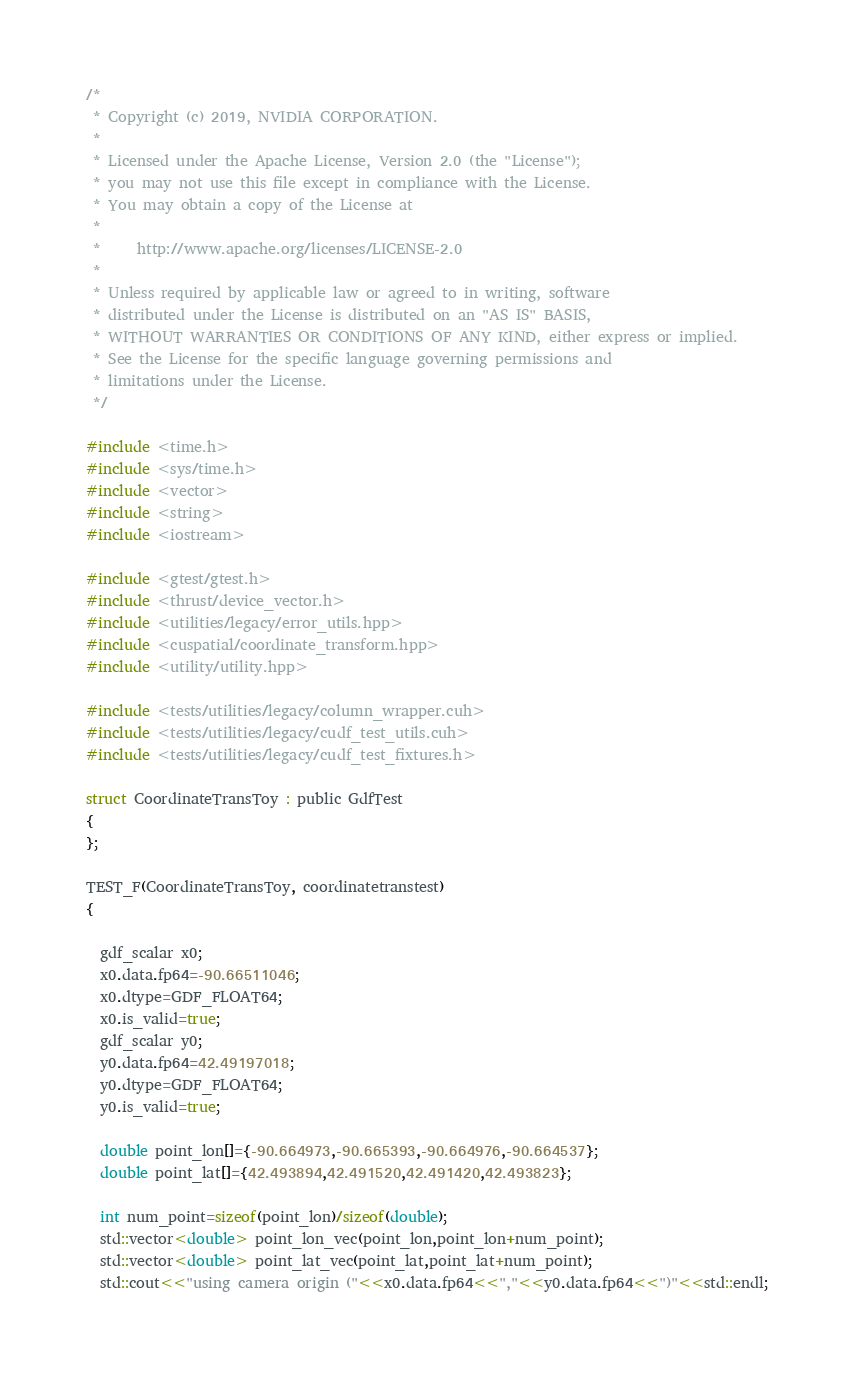Convert code to text. <code><loc_0><loc_0><loc_500><loc_500><_Cuda_>/*
 * Copyright (c) 2019, NVIDIA CORPORATION.
 *
 * Licensed under the Apache License, Version 2.0 (the "License");
 * you may not use this file except in compliance with the License.
 * You may obtain a copy of the License at
 *
 *     http://www.apache.org/licenses/LICENSE-2.0
 *
 * Unless required by applicable law or agreed to in writing, software
 * distributed under the License is distributed on an "AS IS" BASIS,
 * WITHOUT WARRANTIES OR CONDITIONS OF ANY KIND, either express or implied.
 * See the License for the specific language governing permissions and
 * limitations under the License.
 */

#include <time.h>
#include <sys/time.h>
#include <vector>
#include <string>
#include <iostream>

#include <gtest/gtest.h>
#include <thrust/device_vector.h>
#include <utilities/legacy/error_utils.hpp>
#include <cuspatial/coordinate_transform.hpp>
#include <utility/utility.hpp>

#include <tests/utilities/legacy/column_wrapper.cuh>
#include <tests/utilities/legacy/cudf_test_utils.cuh>
#include <tests/utilities/legacy/cudf_test_fixtures.h>

struct CoordinateTransToy : public GdfTest 
{
};   
   
TEST_F(CoordinateTransToy, coordinatetranstest)
{

  gdf_scalar x0; 
  x0.data.fp64=-90.66511046;
  x0.dtype=GDF_FLOAT64;
  x0.is_valid=true;
  gdf_scalar y0;
  y0.data.fp64=42.49197018;
  y0.dtype=GDF_FLOAT64;
  y0.is_valid=true;
  
  double point_lon[]={-90.664973,-90.665393,-90.664976,-90.664537};
  double point_lat[]={42.493894,42.491520,42.491420,42.493823};
  
  int num_point=sizeof(point_lon)/sizeof(double);
  std::vector<double> point_lon_vec(point_lon,point_lon+num_point);
  std::vector<double> point_lat_vec(point_lat,point_lat+num_point);
  std::cout<<"using camera origin ("<<x0.data.fp64<<","<<y0.data.fp64<<")"<<std::endl;</code> 